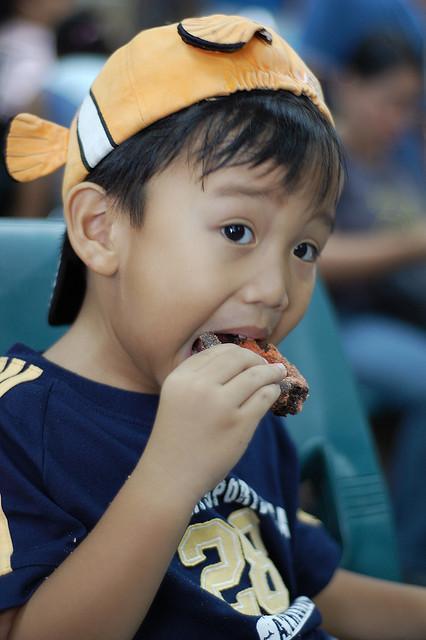How many people are there?
Give a very brief answer. 2. How many cars are parked in the background?
Give a very brief answer. 0. 